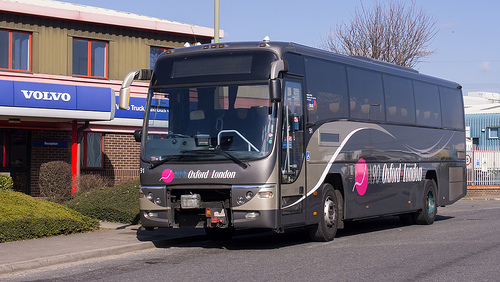Can you describe an advertisement visible on the bus? The bus features a vibrant pink and blue advertisement for 'Oxford London,' presumably a travel service, positioned prominently on the side panel. What does the design and placement of this advertisement tell us about its purpose? Its striking colors and large fonts aim to catch the eye of pedestrians and motorists, effectively promoting intercity travel services offered. 